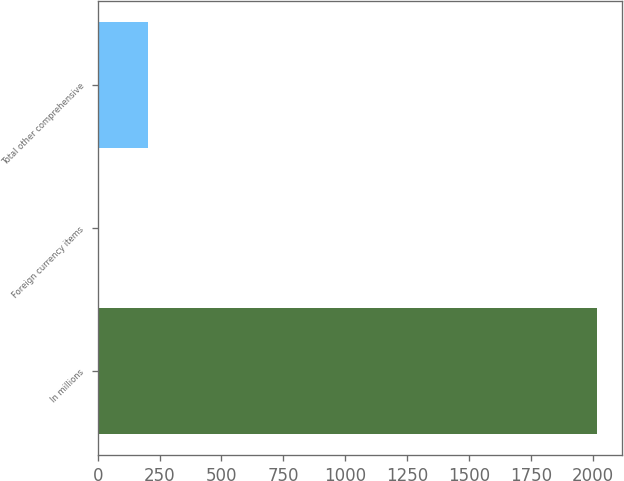<chart> <loc_0><loc_0><loc_500><loc_500><bar_chart><fcel>In millions<fcel>Foreign currency items<fcel>Total other comprehensive<nl><fcel>2015<fcel>1.4<fcel>202.76<nl></chart> 